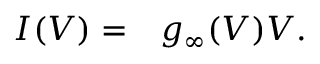Convert formula to latex. <formula><loc_0><loc_0><loc_500><loc_500>\begin{array} { r l } { I ( V ) = } & g _ { \infty } ( V ) V . } \end{array}</formula> 